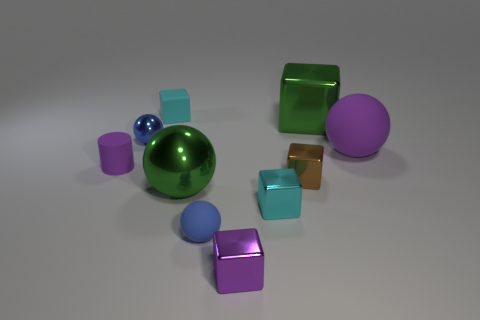What is the material of the other ball that is the same color as the small shiny ball?
Make the answer very short. Rubber. Is the number of small brown things behind the large purple thing less than the number of purple cylinders?
Your answer should be very brief. Yes. Are there any other things that are the same shape as the small purple rubber thing?
Your response must be concise. No. What is the shape of the green thing in front of the tiny blue metallic object?
Offer a terse response. Sphere. There is a large green object to the right of the blue sphere that is in front of the large ball behind the large green ball; what is its shape?
Your answer should be compact. Cube. What number of objects are either blue matte spheres or big brown cubes?
Provide a short and direct response. 1. Do the large metal object left of the green block and the matte object that is on the right side of the large green shiny block have the same shape?
Offer a very short reply. Yes. How many large spheres are behind the purple cylinder and to the left of the purple matte sphere?
Your answer should be very brief. 0. How many other objects are the same size as the cyan matte cube?
Keep it short and to the point. 6. What material is the tiny object that is both behind the large metal sphere and in front of the cylinder?
Ensure brevity in your answer.  Metal. 